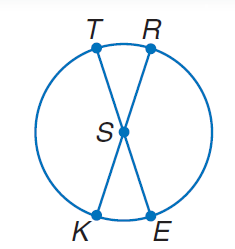Question: In \odot S, m \angle T S R = 42. Find m \widehat K T.
Choices:
A. 21
B. 42
C. 63
D. 138
Answer with the letter. Answer: D 